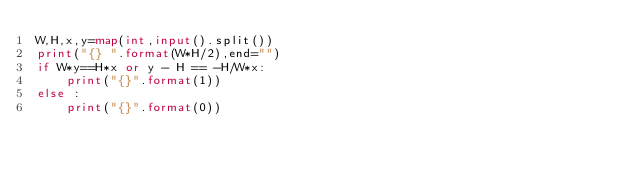<code> <loc_0><loc_0><loc_500><loc_500><_Python_>W,H,x,y=map(int,input().split())
print("{} ".format(W*H/2),end="")
if W*y==H*x or y - H == -H/W*x:
    print("{}".format(1))
else :
    print("{}".format(0))
</code> 